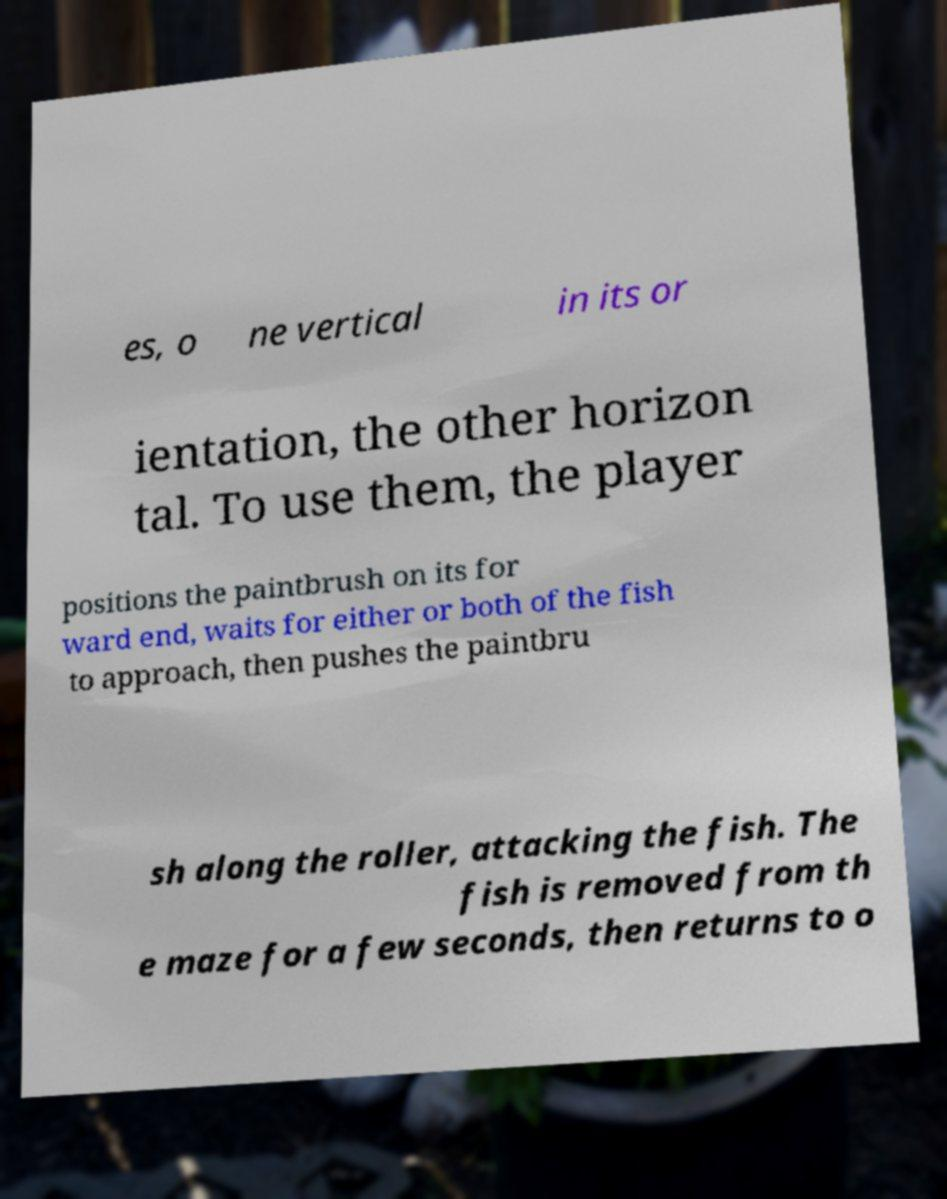Please read and relay the text visible in this image. What does it say? es, o ne vertical in its or ientation, the other horizon tal. To use them, the player positions the paintbrush on its for ward end, waits for either or both of the fish to approach, then pushes the paintbru sh along the roller, attacking the fish. The fish is removed from th e maze for a few seconds, then returns to o 